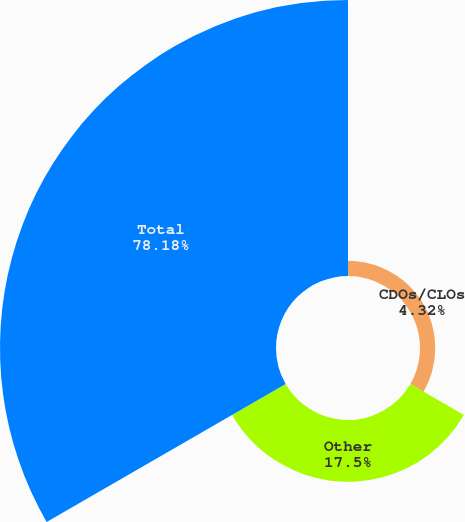Convert chart to OTSL. <chart><loc_0><loc_0><loc_500><loc_500><pie_chart><fcel>CDOs/CLOs<fcel>Other<fcel>Total<nl><fcel>4.32%<fcel>17.5%<fcel>78.18%<nl></chart> 